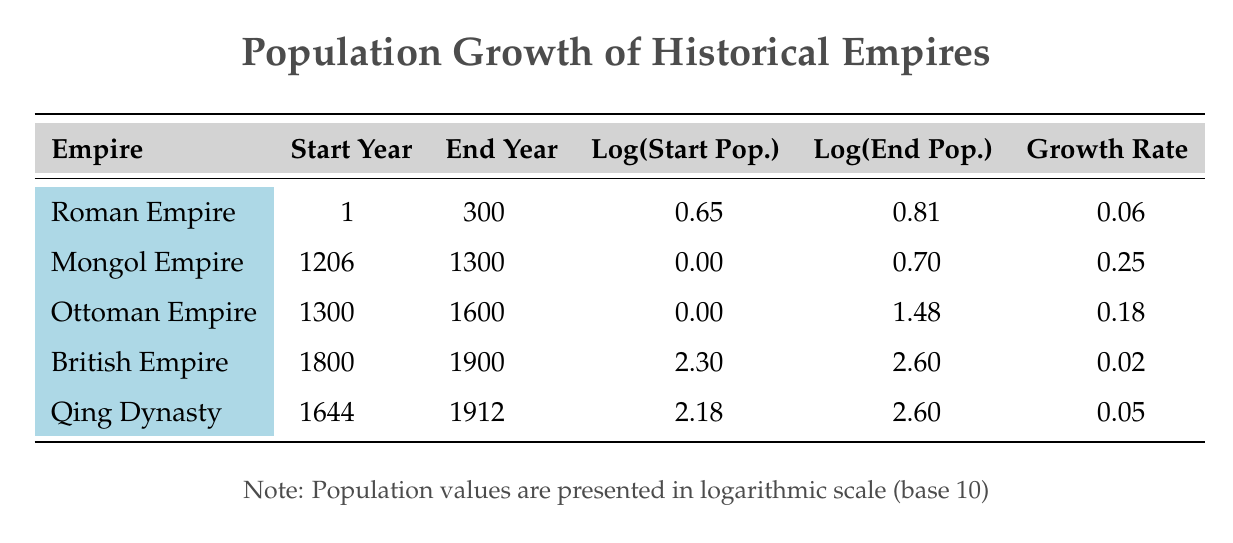What is the growth rate of the Roman Empire? The growth rate for the Roman Empire is directly available in the table under the corresponding column. It shows 0.06.
Answer: 0.06 Which empire had the highest population growth rate, and what was it? By comparing the growth rates listed in the table, I can see that the Mongol Empire had the highest growth rate of 0.25.
Answer: Mongol Empire, 0.25 What was the logarithmic start population of the Ottoman Empire? The table provides the log(start population) value specifically for the Ottoman Empire, which is listed as 0.00.
Answer: 0.00 Calculate the difference in logarithmic population between the start and end year for the British Empire. To find the difference, subtract the log(start population) from the log(end population) for the British Empire: 2.60 - 2.30 = 0.30.
Answer: 0.30 Is the growth rate of the Qing Dynasty greater than that of the Roman Empire? Comparing the growth rates in the table, the Qing Dynasty's growth rate is 0.05, while the Roman Empire's is 0.06. Since 0.05 is less than 0.06, the statement is false.
Answer: No What was the population growth from the start to the end year for the Ottoman Empire in logarithmic terms? For the Ottoman Empire, the log(start population) is 0.00, and the log(end population) is 1.48. The growth is calculated as 1.48 - 0.00 = 1.48.
Answer: 1.48 Which empires had a logarithmic end population greater than 2.0? Reviewing the end population values in logarithmic terms, both the British Empire (2.60) and the Qing Dynasty (2.60) exceed 2.0.
Answer: British Empire, Qing Dynasty What is the average growth rate of all empires listed? To calculate the average growth rate, sum all the growth rates: 0.06 + 0.25 + 0.18 + 0.02 + 0.05 = 0.56. Then divide by the number of empires (5): 0.56 / 5 = 0.112.
Answer: 0.112 Did the Mongol Empire have a lower start population compared to the Ottoman Empire? The Mongol Empire's start population is 1.0, while the Ottoman Empire also starts at 1.0. Therefore, they are equal, making the statement false.
Answer: No 